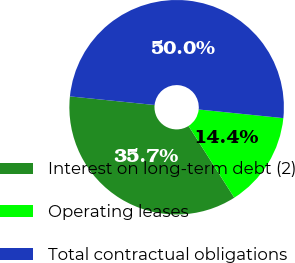Convert chart. <chart><loc_0><loc_0><loc_500><loc_500><pie_chart><fcel>Interest on long-term debt (2)<fcel>Operating leases<fcel>Total contractual obligations<nl><fcel>35.65%<fcel>14.35%<fcel>50.0%<nl></chart> 